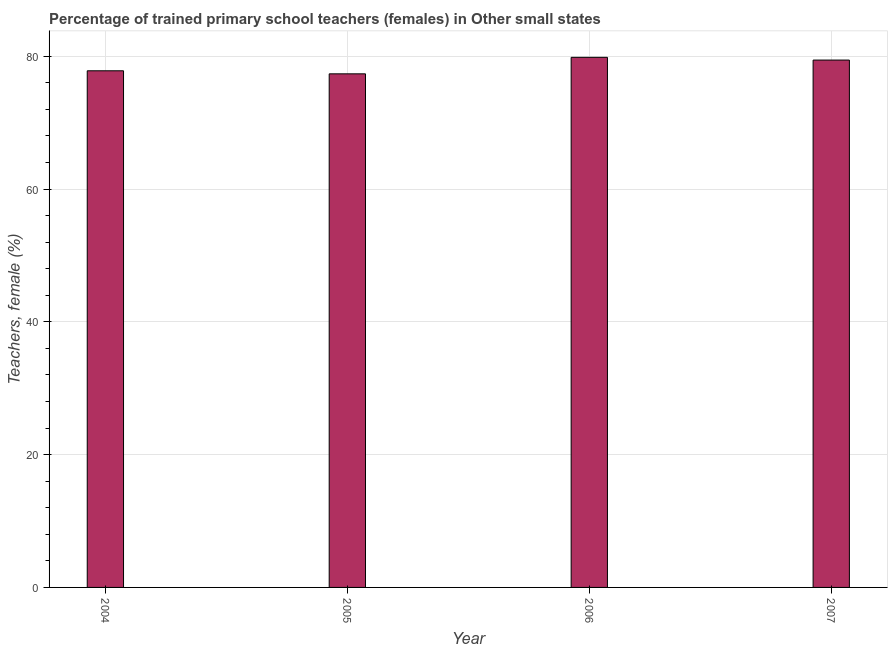What is the title of the graph?
Your response must be concise. Percentage of trained primary school teachers (females) in Other small states. What is the label or title of the Y-axis?
Offer a very short reply. Teachers, female (%). What is the percentage of trained female teachers in 2006?
Provide a short and direct response. 79.84. Across all years, what is the maximum percentage of trained female teachers?
Your response must be concise. 79.84. Across all years, what is the minimum percentage of trained female teachers?
Provide a short and direct response. 77.36. What is the sum of the percentage of trained female teachers?
Your response must be concise. 314.45. What is the difference between the percentage of trained female teachers in 2005 and 2006?
Make the answer very short. -2.49. What is the average percentage of trained female teachers per year?
Your answer should be very brief. 78.61. What is the median percentage of trained female teachers?
Ensure brevity in your answer.  78.62. In how many years, is the percentage of trained female teachers greater than 44 %?
Ensure brevity in your answer.  4. What is the ratio of the percentage of trained female teachers in 2004 to that in 2006?
Your response must be concise. 0.97. Is the difference between the percentage of trained female teachers in 2005 and 2006 greater than the difference between any two years?
Your answer should be very brief. Yes. What is the difference between the highest and the second highest percentage of trained female teachers?
Provide a succinct answer. 0.41. Is the sum of the percentage of trained female teachers in 2006 and 2007 greater than the maximum percentage of trained female teachers across all years?
Your answer should be very brief. Yes. What is the difference between the highest and the lowest percentage of trained female teachers?
Your response must be concise. 2.49. In how many years, is the percentage of trained female teachers greater than the average percentage of trained female teachers taken over all years?
Make the answer very short. 2. How many bars are there?
Make the answer very short. 4. Are all the bars in the graph horizontal?
Offer a very short reply. No. What is the difference between two consecutive major ticks on the Y-axis?
Your answer should be very brief. 20. What is the Teachers, female (%) of 2004?
Your answer should be compact. 77.82. What is the Teachers, female (%) of 2005?
Provide a succinct answer. 77.36. What is the Teachers, female (%) in 2006?
Your response must be concise. 79.84. What is the Teachers, female (%) in 2007?
Provide a short and direct response. 79.43. What is the difference between the Teachers, female (%) in 2004 and 2005?
Offer a terse response. 0.46. What is the difference between the Teachers, female (%) in 2004 and 2006?
Offer a terse response. -2.03. What is the difference between the Teachers, female (%) in 2004 and 2007?
Keep it short and to the point. -1.61. What is the difference between the Teachers, female (%) in 2005 and 2006?
Offer a very short reply. -2.49. What is the difference between the Teachers, female (%) in 2005 and 2007?
Provide a short and direct response. -2.07. What is the difference between the Teachers, female (%) in 2006 and 2007?
Keep it short and to the point. 0.41. What is the ratio of the Teachers, female (%) in 2004 to that in 2005?
Offer a very short reply. 1.01. What is the ratio of the Teachers, female (%) in 2004 to that in 2006?
Keep it short and to the point. 0.97. What is the ratio of the Teachers, female (%) in 2004 to that in 2007?
Provide a short and direct response. 0.98. What is the ratio of the Teachers, female (%) in 2005 to that in 2006?
Provide a succinct answer. 0.97. What is the ratio of the Teachers, female (%) in 2006 to that in 2007?
Offer a terse response. 1. 